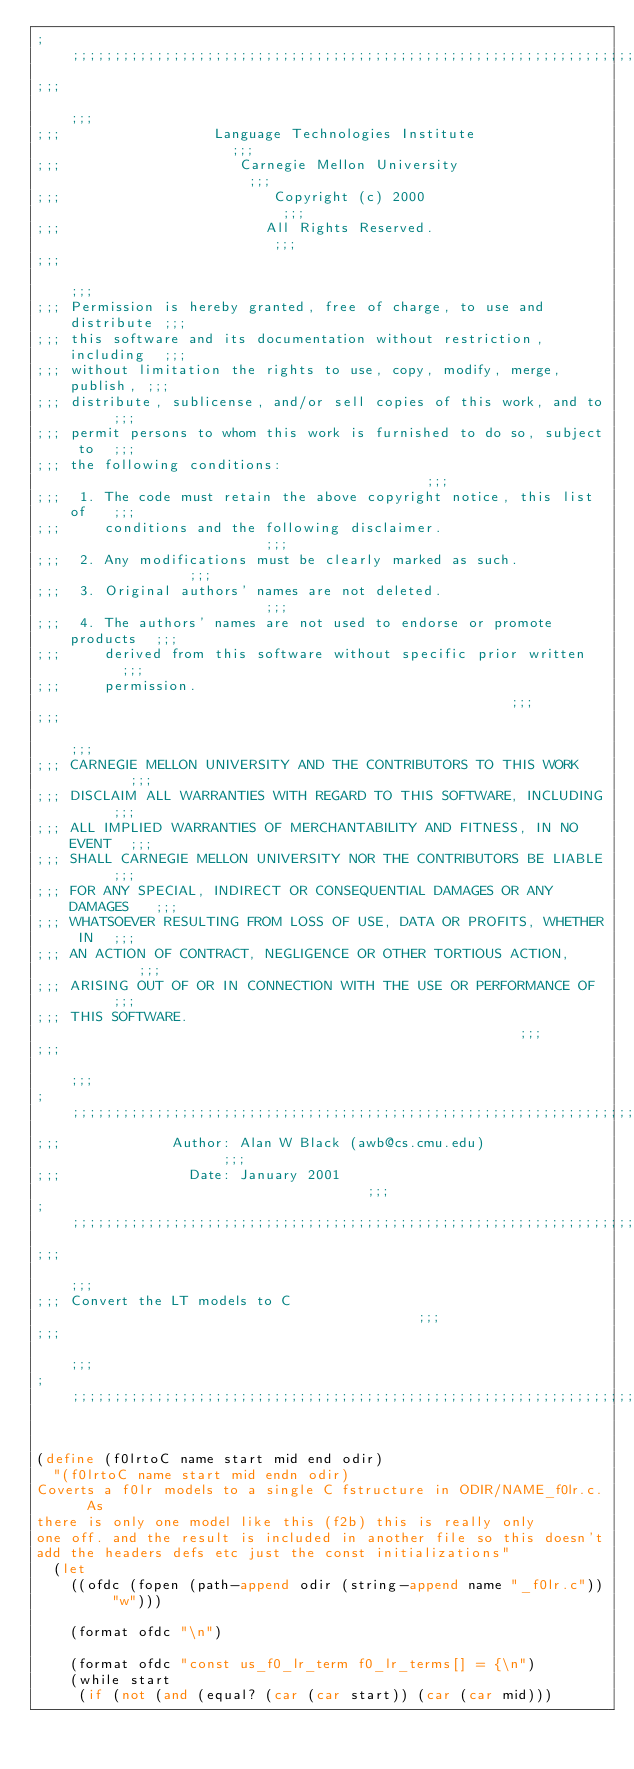Convert code to text. <code><loc_0><loc_0><loc_500><loc_500><_Scheme_>;;;;;;;;;;;;;;;;;;;;;;;;;;;;;;;;;;;;;;;;;;;;;;;;;;;;;;;;;;;;;;;;;;;;;;;;;;;
;;;                                                                     ;;;
;;;                  Language Technologies Institute                    ;;;
;;;                     Carnegie Mellon University                      ;;;
;;;                         Copyright (c) 2000                          ;;;
;;;                        All Rights Reserved.                         ;;;
;;;                                                                     ;;;
;;; Permission is hereby granted, free of charge, to use and distribute ;;;
;;; this software and its documentation without restriction, including  ;;;
;;; without limitation the rights to use, copy, modify, merge, publish, ;;;
;;; distribute, sublicense, and/or sell copies of this work, and to     ;;;
;;; permit persons to whom this work is furnished to do so, subject to  ;;;
;;; the following conditions:                                           ;;;
;;;  1. The code must retain the above copyright notice, this list of   ;;;
;;;     conditions and the following disclaimer.                        ;;;
;;;  2. Any modifications must be clearly marked as such.               ;;;
;;;  3. Original authors' names are not deleted.                        ;;;
;;;  4. The authors' names are not used to endorse or promote products  ;;;
;;;     derived from this software without specific prior written       ;;;
;;;     permission.                                                     ;;;
;;;                                                                     ;;;
;;; CARNEGIE MELLON UNIVERSITY AND THE CONTRIBUTORS TO THIS WORK        ;;;
;;; DISCLAIM ALL WARRANTIES WITH REGARD TO THIS SOFTWARE, INCLUDING     ;;;
;;; ALL IMPLIED WARRANTIES OF MERCHANTABILITY AND FITNESS, IN NO EVENT  ;;;
;;; SHALL CARNEGIE MELLON UNIVERSITY NOR THE CONTRIBUTORS BE LIABLE     ;;;
;;; FOR ANY SPECIAL, INDIRECT OR CONSEQUENTIAL DAMAGES OR ANY DAMAGES   ;;;
;;; WHATSOEVER RESULTING FROM LOSS OF USE, DATA OR PROFITS, WHETHER IN  ;;;
;;; AN ACTION OF CONTRACT, NEGLIGENCE OR OTHER TORTIOUS ACTION,         ;;;
;;; ARISING OUT OF OR IN CONNECTION WITH THE USE OR PERFORMANCE OF      ;;;
;;; THIS SOFTWARE.                                                      ;;;
;;;                                                                     ;;;
;;;;;;;;;;;;;;;;;;;;;;;;;;;;;;;;;;;;;;;;;;;;;;;;;;;;;;;;;;;;;;;;;;;;;;;;;;;
;;;             Author: Alan W Black (awb@cs.cmu.edu)                   ;;;
;;;               Date: January 2001                                    ;;;
;;;;;;;;;;;;;;;;;;;;;;;;;;;;;;;;;;;;;;;;;;;;;;;;;;;;;;;;;;;;;;;;;;;;;;;;;;;
;;;                                                                     ;;;
;;; Convert the LT models to C                                          ;;;
;;;                                                                     ;;;
;;;;;;;;;;;;;;;;;;;;;;;;;;;;;;;;;;;;;;;;;;;;;;;;;;;;;;;;;;;;;;;;;;;;;;;;;;;


(define (f0lrtoC name start mid end odir)
  "(f0lrtoC name start mid endn odir)
Coverts a f0lr models to a single C fstructure in ODIR/NAME_f0lr.c.  As
there is only one model like this (f2b) this is really only
one off. and the result is included in another file so this doesn't
add the headers defs etc just the const initializations"
  (let 
    ((ofdc (fopen (path-append odir (string-append name "_f0lr.c")) "w")))

    (format ofdc "\n")

    (format ofdc "const us_f0_lr_term f0_lr_terms[] = {\n")
    (while start
     (if (not (and (equal? (car (car start)) (car (car mid)))</code> 